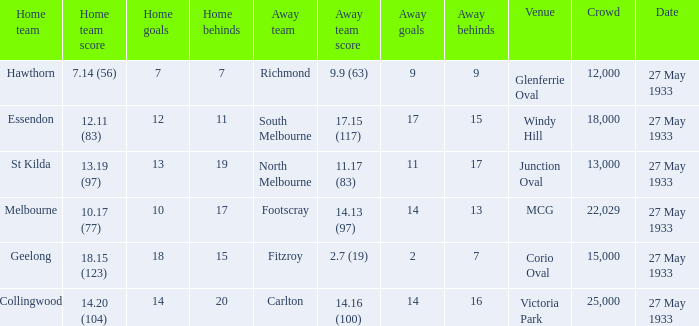During st kilda's home game, what was the number of people in the crowd? 13000.0. 